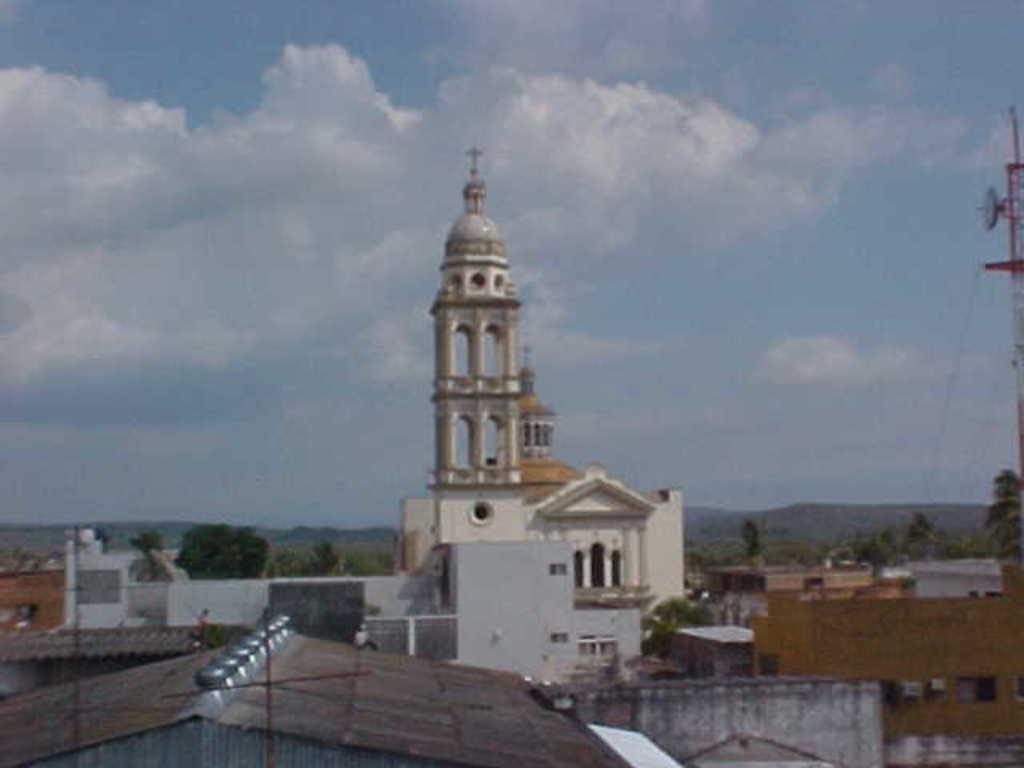Could you give a brief overview of what you see in this image? This image is taken outdoors. At the top of the image there is the sky with clouds. In the middle of the image there are many houses and a few buildings. There is an architecture with walls and pillars. There are many trees with leaves, stems and branches. In the background there are a few hills. On the right side of the image there is a tower. 